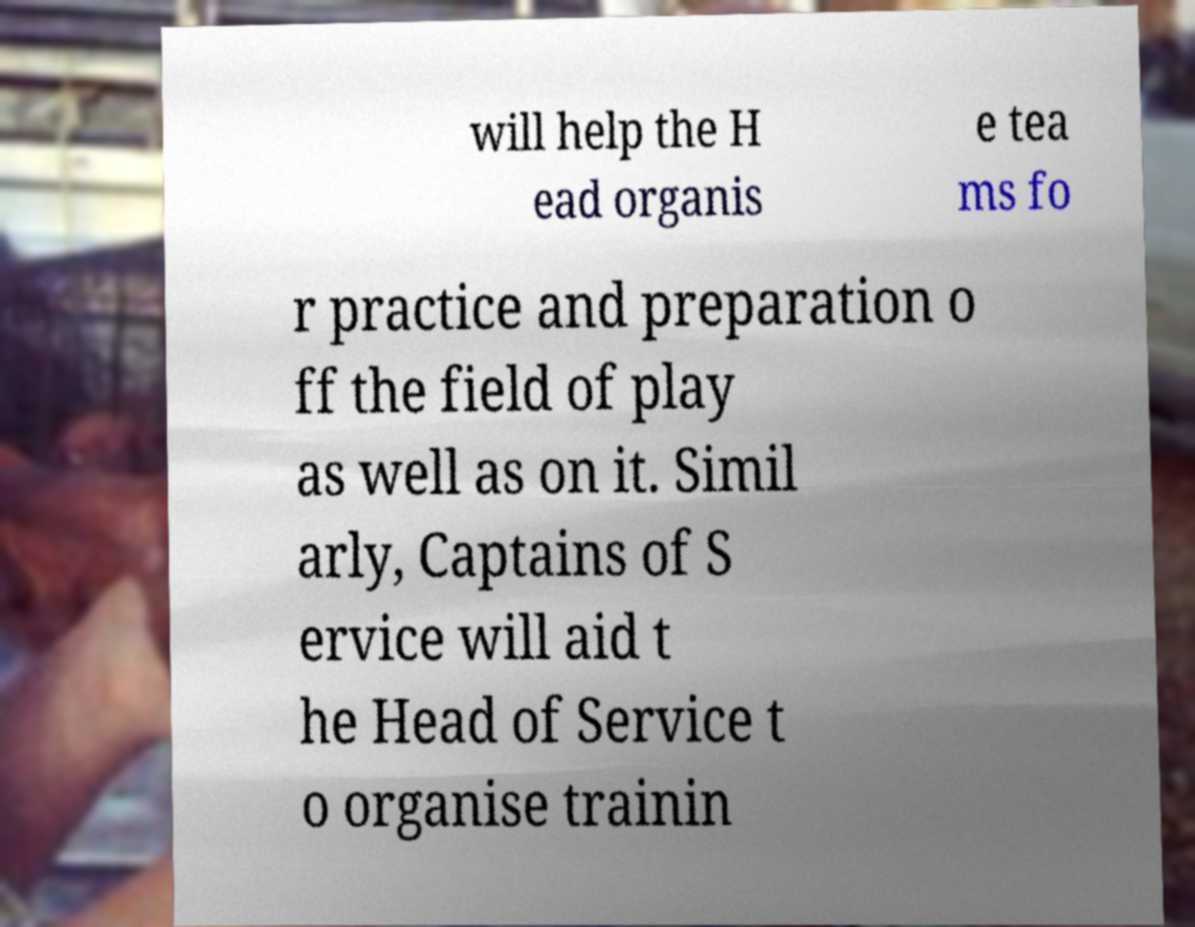Could you extract and type out the text from this image? will help the H ead organis e tea ms fo r practice and preparation o ff the field of play as well as on it. Simil arly, Captains of S ervice will aid t he Head of Service t o organise trainin 